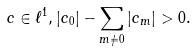Convert formula to latex. <formula><loc_0><loc_0><loc_500><loc_500>c \in \ell ^ { 1 } , | c _ { 0 } | - \sum _ { m \not = 0 } | c _ { m } | > 0 .</formula> 